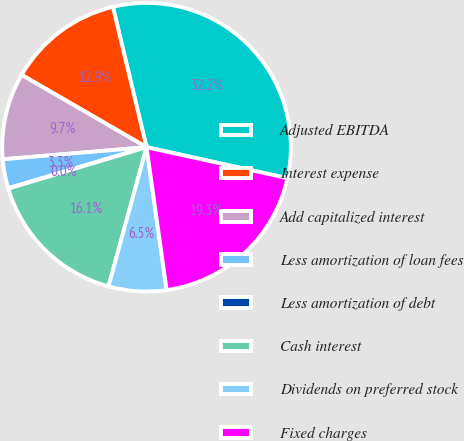Convert chart. <chart><loc_0><loc_0><loc_500><loc_500><pie_chart><fcel>Adjusted EBITDA<fcel>Interest expense<fcel>Add capitalized interest<fcel>Less amortization of loan fees<fcel>Less amortization of debt<fcel>Cash interest<fcel>Dividends on preferred stock<fcel>Fixed charges<nl><fcel>32.19%<fcel>12.9%<fcel>9.69%<fcel>3.26%<fcel>0.04%<fcel>16.12%<fcel>6.47%<fcel>19.33%<nl></chart> 